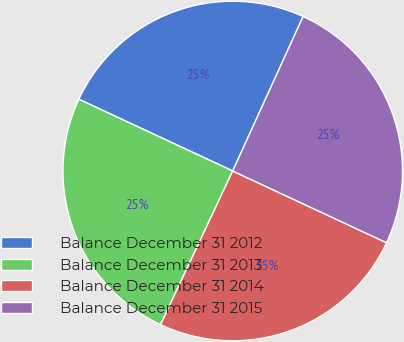Convert chart to OTSL. <chart><loc_0><loc_0><loc_500><loc_500><pie_chart><fcel>Balance December 31 2012<fcel>Balance December 31 2013<fcel>Balance December 31 2014<fcel>Balance December 31 2015<nl><fcel>24.86%<fcel>24.96%<fcel>25.04%<fcel>25.14%<nl></chart> 